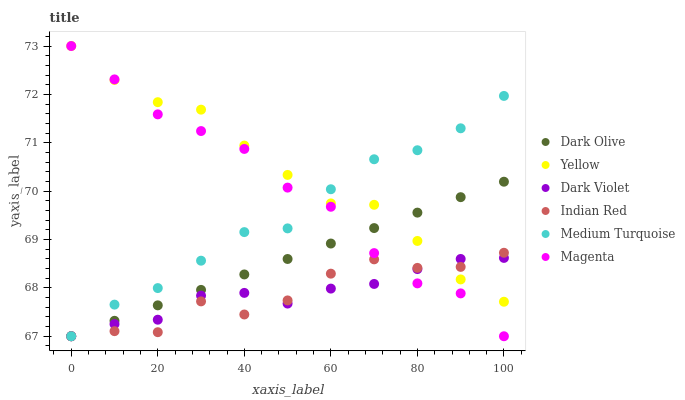Does Indian Red have the minimum area under the curve?
Answer yes or no. Yes. Does Yellow have the maximum area under the curve?
Answer yes or no. Yes. Does Dark Olive have the minimum area under the curve?
Answer yes or no. No. Does Dark Olive have the maximum area under the curve?
Answer yes or no. No. Is Dark Olive the smoothest?
Answer yes or no. Yes. Is Indian Red the roughest?
Answer yes or no. Yes. Is Dark Violet the smoothest?
Answer yes or no. No. Is Dark Violet the roughest?
Answer yes or no. No. Does Medium Turquoise have the lowest value?
Answer yes or no. Yes. Does Yellow have the lowest value?
Answer yes or no. No. Does Magenta have the highest value?
Answer yes or no. Yes. Does Dark Olive have the highest value?
Answer yes or no. No. Does Indian Red intersect Yellow?
Answer yes or no. Yes. Is Indian Red less than Yellow?
Answer yes or no. No. Is Indian Red greater than Yellow?
Answer yes or no. No. 